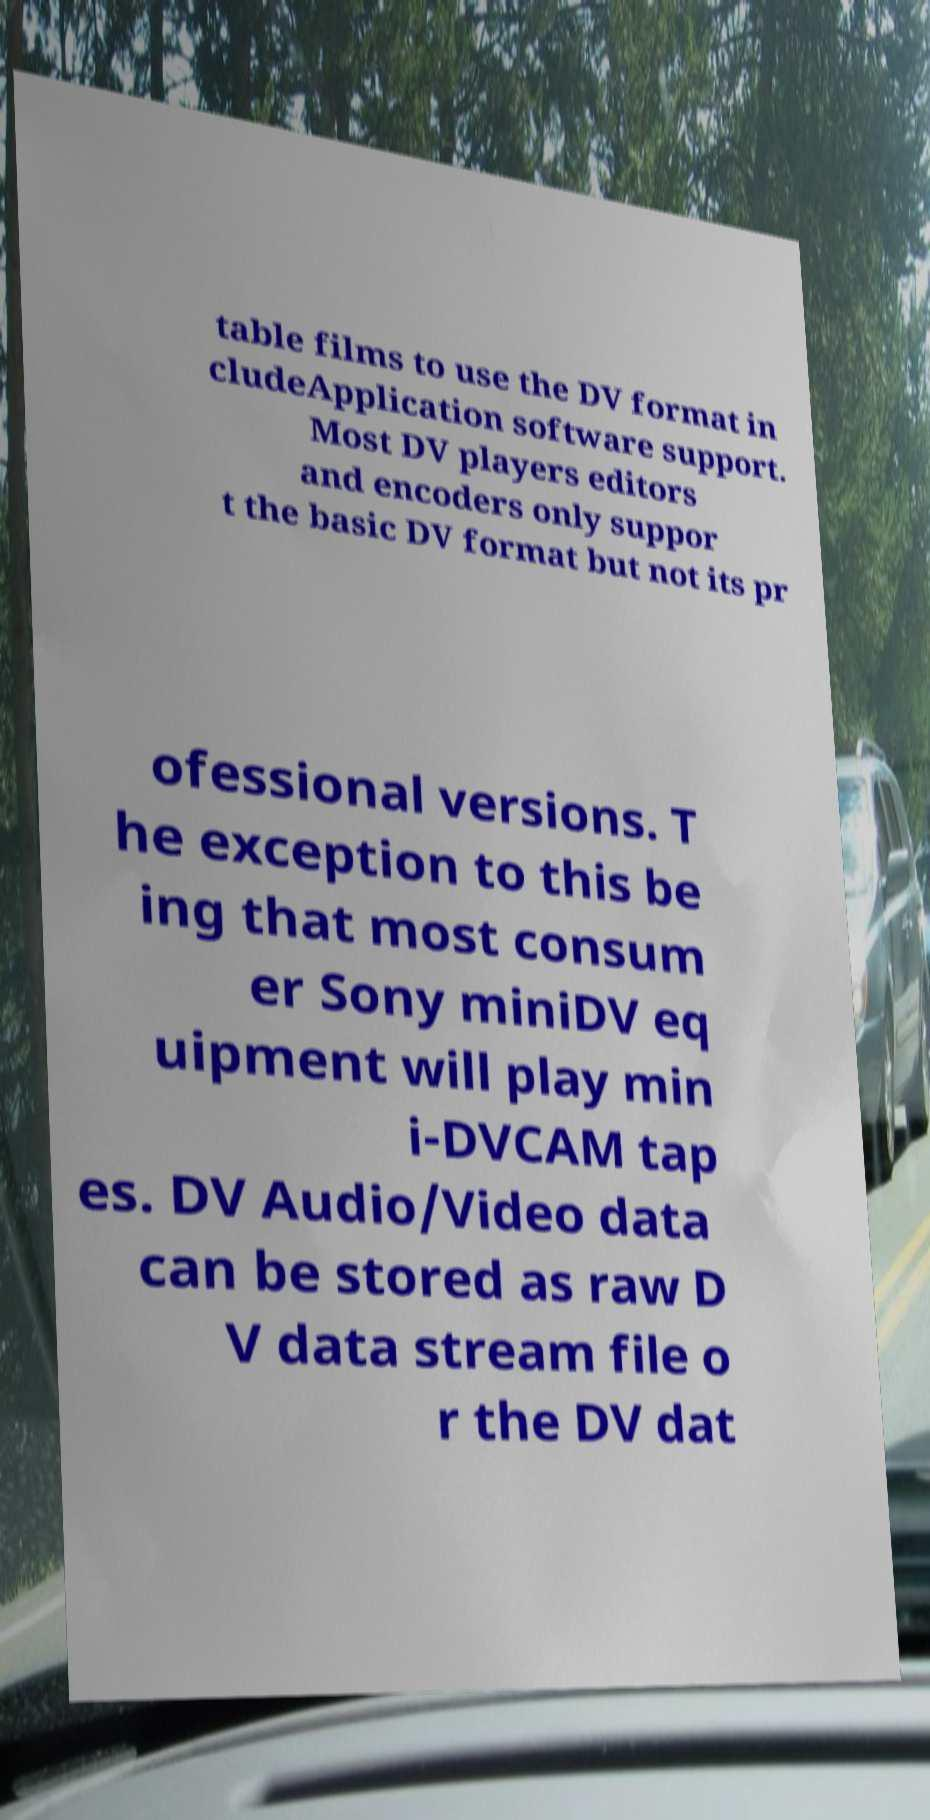Can you accurately transcribe the text from the provided image for me? table films to use the DV format in cludeApplication software support. Most DV players editors and encoders only suppor t the basic DV format but not its pr ofessional versions. T he exception to this be ing that most consum er Sony miniDV eq uipment will play min i-DVCAM tap es. DV Audio/Video data can be stored as raw D V data stream file o r the DV dat 